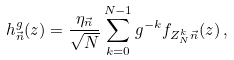Convert formula to latex. <formula><loc_0><loc_0><loc_500><loc_500>h _ { \vec { n } } ^ { g } ( z ) = \frac { \eta _ { \vec { n } } } { \sqrt { N } } \sum _ { k = 0 } ^ { N - 1 } g ^ { - k } f _ { Z _ { N } ^ { k } \vec { n } } ( z ) \, ,</formula> 